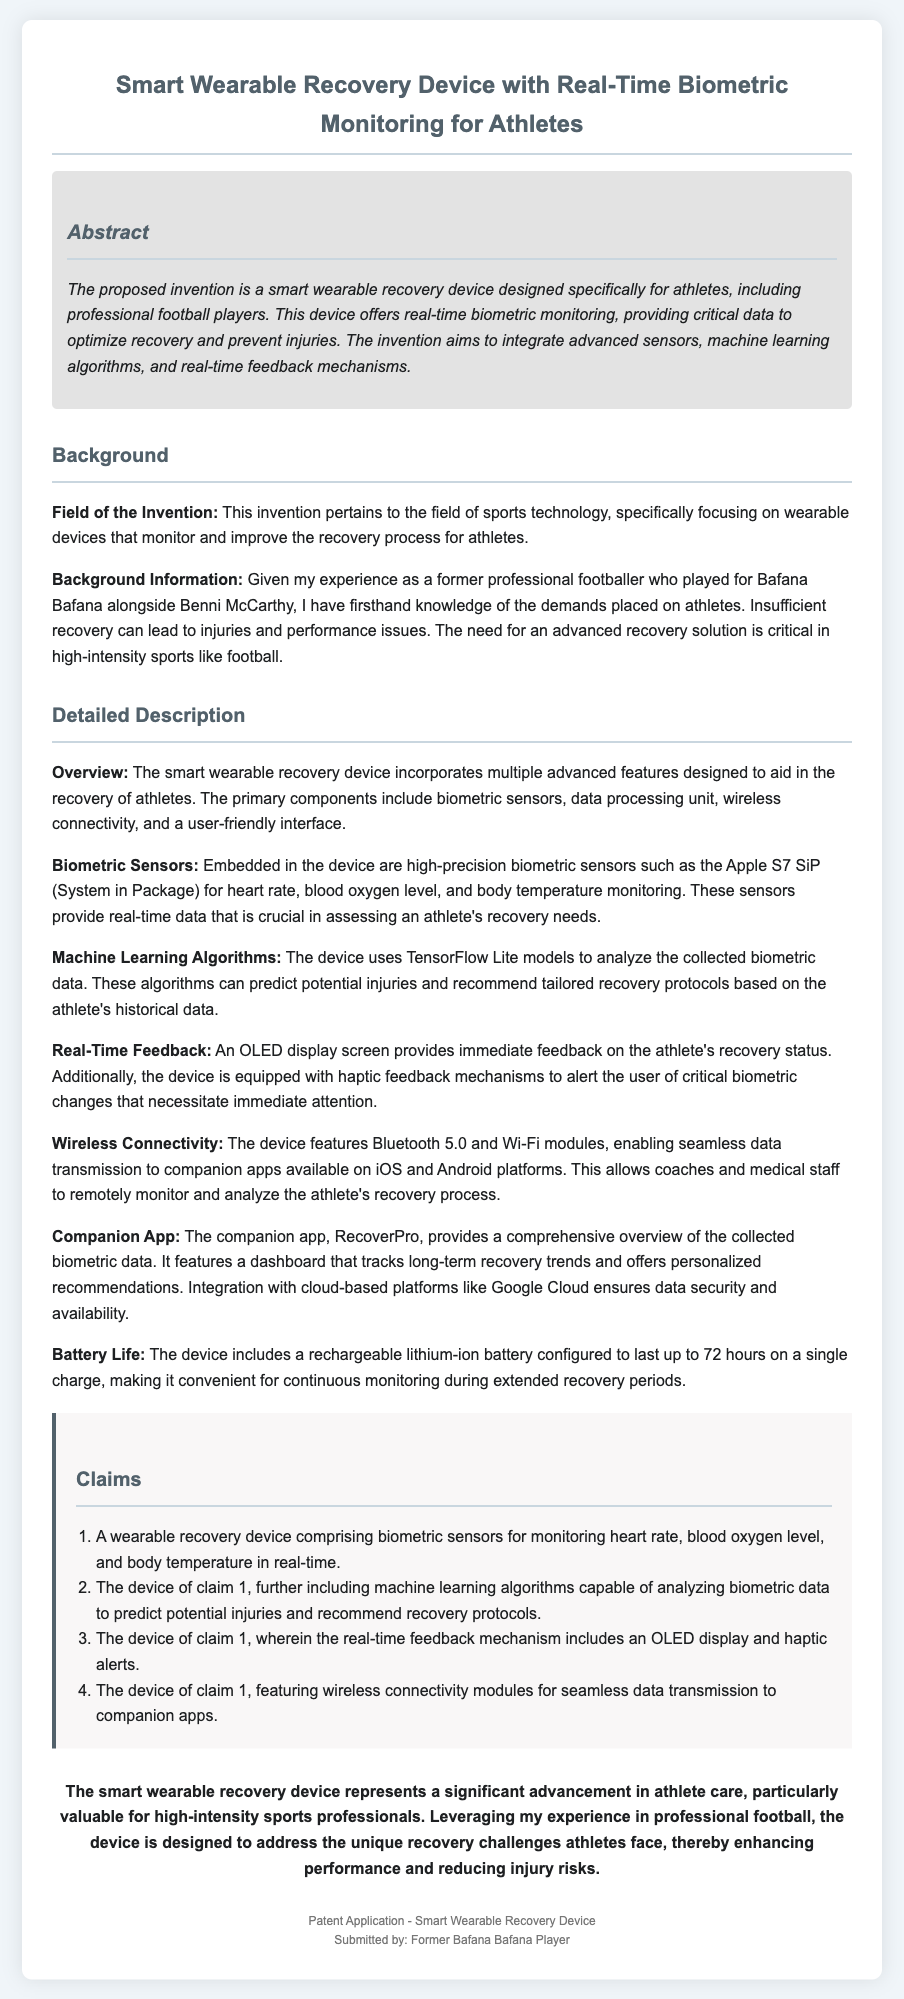What is the title of the invention? The title is explicitly stated at the top of the document.
Answer: Smart Wearable Recovery Device with Real-Time Biometric Monitoring for Athletes How many claims are included in the patent application? The claims are listed in an ordered format, which indicates the total number of claims.
Answer: Four What type of sensors are embedded in the device? The specific type of sensors is mentioned under the Biometric Sensors section.
Answer: Biometric sensors Which machine learning framework is used in the device? The detailed description specifies the machine learning framework used in the device.
Answer: TensorFlow Lite What is the battery life of the device? The battery life is described in hours in the Detailed Description section.
Answer: 72 hours What companion app is mentioned for the device? The name of the companion app is provided in the detailed description.
Answer: RecoverPro What is the primary purpose of the wearable recovery device? The purpose is summarized in the Abstract section of the document.
Answer: Optimize recovery and prevent injuries What connectivity standard does the device support? The wireless connectivity standards mentioned in the document specify the types supported by the device.
Answer: Bluetooth 5.0 and Wi-Fi Who submitted the patent application? The footer provides the name of the individual who submitted the application.
Answer: Former Bafana Bafana Player 